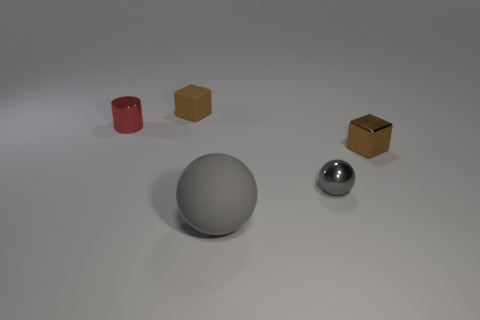There is a thing that is the same color as the matte ball; what is its material?
Your response must be concise. Metal. What is the material of the small brown object that is to the left of the big gray sphere?
Give a very brief answer. Rubber. Is the big matte thing the same shape as the gray metallic thing?
Your response must be concise. Yes. What number of other things are there of the same shape as the small red object?
Your response must be concise. 0. There is a object right of the gray metal ball; what color is it?
Keep it short and to the point. Brown. Do the cylinder and the gray rubber thing have the same size?
Make the answer very short. No. There is a cube in front of the brown block that is behind the small brown metallic cube; what is it made of?
Offer a terse response. Metal. What number of shiny blocks have the same color as the small matte thing?
Keep it short and to the point. 1. Is the number of small red metal cylinders that are behind the small brown rubber block less than the number of small gray matte cubes?
Your answer should be compact. No. What color is the object behind the metallic object on the left side of the big matte object?
Ensure brevity in your answer.  Brown. 